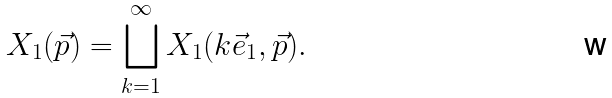Convert formula to latex. <formula><loc_0><loc_0><loc_500><loc_500>X _ { 1 } ( \vec { p } ) = \bigsqcup _ { k = 1 } ^ { \infty } X _ { 1 } ( k \vec { e } _ { 1 } , \vec { p } ) .</formula> 